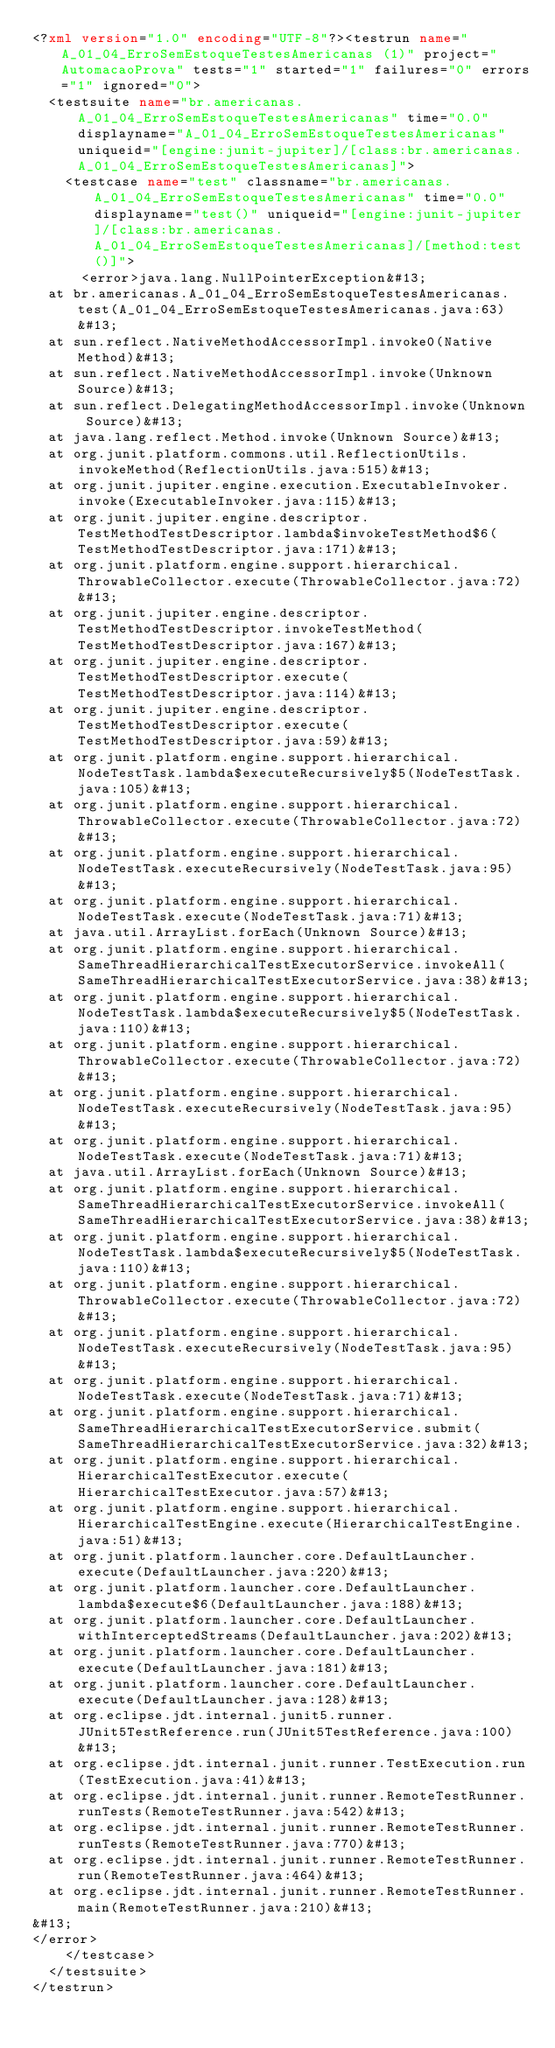<code> <loc_0><loc_0><loc_500><loc_500><_XML_><?xml version="1.0" encoding="UTF-8"?><testrun name="A_01_04_ErroSemEstoqueTestesAmericanas (1)" project="AutomacaoProva" tests="1" started="1" failures="0" errors="1" ignored="0">
  <testsuite name="br.americanas.A_01_04_ErroSemEstoqueTestesAmericanas" time="0.0" displayname="A_01_04_ErroSemEstoqueTestesAmericanas" uniqueid="[engine:junit-jupiter]/[class:br.americanas.A_01_04_ErroSemEstoqueTestesAmericanas]">
    <testcase name="test" classname="br.americanas.A_01_04_ErroSemEstoqueTestesAmericanas" time="0.0" displayname="test()" uniqueid="[engine:junit-jupiter]/[class:br.americanas.A_01_04_ErroSemEstoqueTestesAmericanas]/[method:test()]">
      <error>java.lang.NullPointerException&#13;
	at br.americanas.A_01_04_ErroSemEstoqueTestesAmericanas.test(A_01_04_ErroSemEstoqueTestesAmericanas.java:63)&#13;
	at sun.reflect.NativeMethodAccessorImpl.invoke0(Native Method)&#13;
	at sun.reflect.NativeMethodAccessorImpl.invoke(Unknown Source)&#13;
	at sun.reflect.DelegatingMethodAccessorImpl.invoke(Unknown Source)&#13;
	at java.lang.reflect.Method.invoke(Unknown Source)&#13;
	at org.junit.platform.commons.util.ReflectionUtils.invokeMethod(ReflectionUtils.java:515)&#13;
	at org.junit.jupiter.engine.execution.ExecutableInvoker.invoke(ExecutableInvoker.java:115)&#13;
	at org.junit.jupiter.engine.descriptor.TestMethodTestDescriptor.lambda$invokeTestMethod$6(TestMethodTestDescriptor.java:171)&#13;
	at org.junit.platform.engine.support.hierarchical.ThrowableCollector.execute(ThrowableCollector.java:72)&#13;
	at org.junit.jupiter.engine.descriptor.TestMethodTestDescriptor.invokeTestMethod(TestMethodTestDescriptor.java:167)&#13;
	at org.junit.jupiter.engine.descriptor.TestMethodTestDescriptor.execute(TestMethodTestDescriptor.java:114)&#13;
	at org.junit.jupiter.engine.descriptor.TestMethodTestDescriptor.execute(TestMethodTestDescriptor.java:59)&#13;
	at org.junit.platform.engine.support.hierarchical.NodeTestTask.lambda$executeRecursively$5(NodeTestTask.java:105)&#13;
	at org.junit.platform.engine.support.hierarchical.ThrowableCollector.execute(ThrowableCollector.java:72)&#13;
	at org.junit.platform.engine.support.hierarchical.NodeTestTask.executeRecursively(NodeTestTask.java:95)&#13;
	at org.junit.platform.engine.support.hierarchical.NodeTestTask.execute(NodeTestTask.java:71)&#13;
	at java.util.ArrayList.forEach(Unknown Source)&#13;
	at org.junit.platform.engine.support.hierarchical.SameThreadHierarchicalTestExecutorService.invokeAll(SameThreadHierarchicalTestExecutorService.java:38)&#13;
	at org.junit.platform.engine.support.hierarchical.NodeTestTask.lambda$executeRecursively$5(NodeTestTask.java:110)&#13;
	at org.junit.platform.engine.support.hierarchical.ThrowableCollector.execute(ThrowableCollector.java:72)&#13;
	at org.junit.platform.engine.support.hierarchical.NodeTestTask.executeRecursively(NodeTestTask.java:95)&#13;
	at org.junit.platform.engine.support.hierarchical.NodeTestTask.execute(NodeTestTask.java:71)&#13;
	at java.util.ArrayList.forEach(Unknown Source)&#13;
	at org.junit.platform.engine.support.hierarchical.SameThreadHierarchicalTestExecutorService.invokeAll(SameThreadHierarchicalTestExecutorService.java:38)&#13;
	at org.junit.platform.engine.support.hierarchical.NodeTestTask.lambda$executeRecursively$5(NodeTestTask.java:110)&#13;
	at org.junit.platform.engine.support.hierarchical.ThrowableCollector.execute(ThrowableCollector.java:72)&#13;
	at org.junit.platform.engine.support.hierarchical.NodeTestTask.executeRecursively(NodeTestTask.java:95)&#13;
	at org.junit.platform.engine.support.hierarchical.NodeTestTask.execute(NodeTestTask.java:71)&#13;
	at org.junit.platform.engine.support.hierarchical.SameThreadHierarchicalTestExecutorService.submit(SameThreadHierarchicalTestExecutorService.java:32)&#13;
	at org.junit.platform.engine.support.hierarchical.HierarchicalTestExecutor.execute(HierarchicalTestExecutor.java:57)&#13;
	at org.junit.platform.engine.support.hierarchical.HierarchicalTestEngine.execute(HierarchicalTestEngine.java:51)&#13;
	at org.junit.platform.launcher.core.DefaultLauncher.execute(DefaultLauncher.java:220)&#13;
	at org.junit.platform.launcher.core.DefaultLauncher.lambda$execute$6(DefaultLauncher.java:188)&#13;
	at org.junit.platform.launcher.core.DefaultLauncher.withInterceptedStreams(DefaultLauncher.java:202)&#13;
	at org.junit.platform.launcher.core.DefaultLauncher.execute(DefaultLauncher.java:181)&#13;
	at org.junit.platform.launcher.core.DefaultLauncher.execute(DefaultLauncher.java:128)&#13;
	at org.eclipse.jdt.internal.junit5.runner.JUnit5TestReference.run(JUnit5TestReference.java:100)&#13;
	at org.eclipse.jdt.internal.junit.runner.TestExecution.run(TestExecution.java:41)&#13;
	at org.eclipse.jdt.internal.junit.runner.RemoteTestRunner.runTests(RemoteTestRunner.java:542)&#13;
	at org.eclipse.jdt.internal.junit.runner.RemoteTestRunner.runTests(RemoteTestRunner.java:770)&#13;
	at org.eclipse.jdt.internal.junit.runner.RemoteTestRunner.run(RemoteTestRunner.java:464)&#13;
	at org.eclipse.jdt.internal.junit.runner.RemoteTestRunner.main(RemoteTestRunner.java:210)&#13;
&#13;
</error>
    </testcase>
  </testsuite>
</testrun>
</code> 